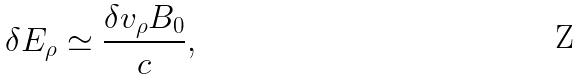<formula> <loc_0><loc_0><loc_500><loc_500>\delta E _ { \rho } \simeq \frac { \delta v _ { \rho } B _ { 0 } } { c } ,</formula> 